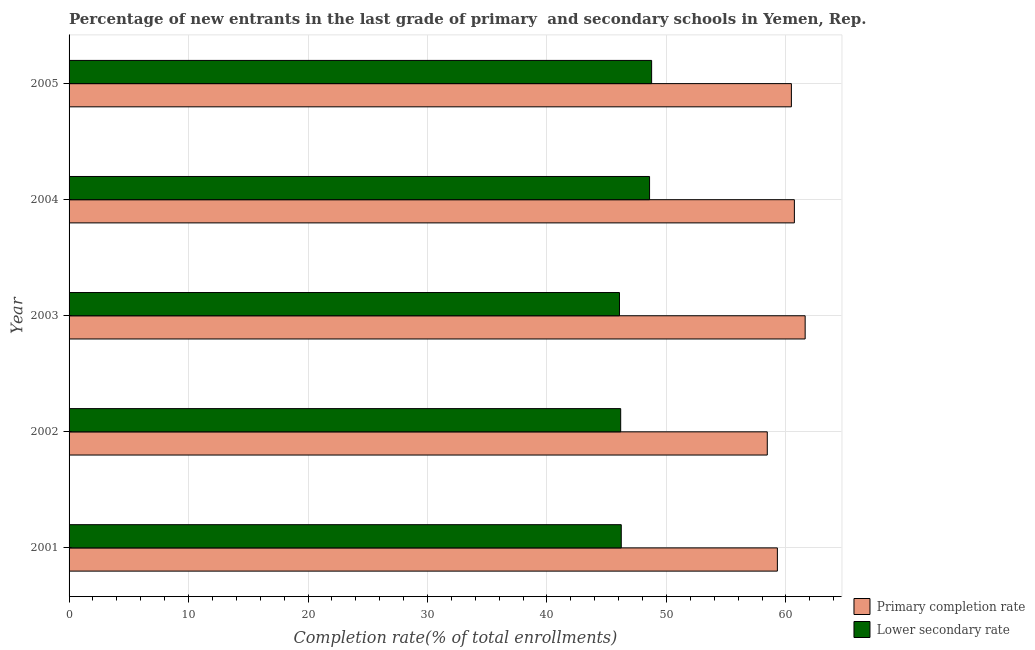How many different coloured bars are there?
Keep it short and to the point. 2. Are the number of bars on each tick of the Y-axis equal?
Make the answer very short. Yes. How many bars are there on the 4th tick from the top?
Give a very brief answer. 2. In how many cases, is the number of bars for a given year not equal to the number of legend labels?
Ensure brevity in your answer.  0. What is the completion rate in primary schools in 2003?
Provide a short and direct response. 61.61. Across all years, what is the maximum completion rate in secondary schools?
Offer a very short reply. 48.76. Across all years, what is the minimum completion rate in primary schools?
Provide a succinct answer. 58.44. What is the total completion rate in primary schools in the graph?
Your answer should be compact. 300.51. What is the difference between the completion rate in primary schools in 2001 and that in 2002?
Offer a terse response. 0.84. What is the difference between the completion rate in primary schools in 2002 and the completion rate in secondary schools in 2003?
Give a very brief answer. 12.37. What is the average completion rate in primary schools per year?
Your response must be concise. 60.1. In the year 2001, what is the difference between the completion rate in primary schools and completion rate in secondary schools?
Your response must be concise. 13.07. In how many years, is the completion rate in primary schools greater than 20 %?
Ensure brevity in your answer.  5. Is the difference between the completion rate in secondary schools in 2002 and 2005 greater than the difference between the completion rate in primary schools in 2002 and 2005?
Provide a succinct answer. No. What is the difference between the highest and the second highest completion rate in secondary schools?
Make the answer very short. 0.17. What is the difference between the highest and the lowest completion rate in secondary schools?
Give a very brief answer. 2.69. In how many years, is the completion rate in secondary schools greater than the average completion rate in secondary schools taken over all years?
Keep it short and to the point. 2. Is the sum of the completion rate in secondary schools in 2002 and 2005 greater than the maximum completion rate in primary schools across all years?
Your answer should be very brief. Yes. What does the 2nd bar from the top in 2002 represents?
Make the answer very short. Primary completion rate. What does the 1st bar from the bottom in 2004 represents?
Your response must be concise. Primary completion rate. Are all the bars in the graph horizontal?
Your response must be concise. Yes. Are the values on the major ticks of X-axis written in scientific E-notation?
Offer a terse response. No. Does the graph contain any zero values?
Your answer should be very brief. No. Does the graph contain grids?
Make the answer very short. Yes. What is the title of the graph?
Provide a short and direct response. Percentage of new entrants in the last grade of primary  and secondary schools in Yemen, Rep. What is the label or title of the X-axis?
Give a very brief answer. Completion rate(% of total enrollments). What is the label or title of the Y-axis?
Your answer should be compact. Year. What is the Completion rate(% of total enrollments) in Primary completion rate in 2001?
Give a very brief answer. 59.29. What is the Completion rate(% of total enrollments) of Lower secondary rate in 2001?
Offer a very short reply. 46.22. What is the Completion rate(% of total enrollments) in Primary completion rate in 2002?
Keep it short and to the point. 58.44. What is the Completion rate(% of total enrollments) in Lower secondary rate in 2002?
Provide a short and direct response. 46.17. What is the Completion rate(% of total enrollments) in Primary completion rate in 2003?
Give a very brief answer. 61.61. What is the Completion rate(% of total enrollments) of Lower secondary rate in 2003?
Keep it short and to the point. 46.07. What is the Completion rate(% of total enrollments) of Primary completion rate in 2004?
Offer a terse response. 60.71. What is the Completion rate(% of total enrollments) of Lower secondary rate in 2004?
Make the answer very short. 48.59. What is the Completion rate(% of total enrollments) of Primary completion rate in 2005?
Provide a succinct answer. 60.46. What is the Completion rate(% of total enrollments) of Lower secondary rate in 2005?
Offer a very short reply. 48.76. Across all years, what is the maximum Completion rate(% of total enrollments) of Primary completion rate?
Give a very brief answer. 61.61. Across all years, what is the maximum Completion rate(% of total enrollments) of Lower secondary rate?
Provide a short and direct response. 48.76. Across all years, what is the minimum Completion rate(% of total enrollments) of Primary completion rate?
Offer a terse response. 58.44. Across all years, what is the minimum Completion rate(% of total enrollments) of Lower secondary rate?
Your response must be concise. 46.07. What is the total Completion rate(% of total enrollments) in Primary completion rate in the graph?
Your response must be concise. 300.51. What is the total Completion rate(% of total enrollments) in Lower secondary rate in the graph?
Offer a terse response. 235.82. What is the difference between the Completion rate(% of total enrollments) in Primary completion rate in 2001 and that in 2002?
Give a very brief answer. 0.85. What is the difference between the Completion rate(% of total enrollments) of Lower secondary rate in 2001 and that in 2002?
Make the answer very short. 0.05. What is the difference between the Completion rate(% of total enrollments) in Primary completion rate in 2001 and that in 2003?
Provide a short and direct response. -2.33. What is the difference between the Completion rate(% of total enrollments) in Lower secondary rate in 2001 and that in 2003?
Your answer should be very brief. 0.15. What is the difference between the Completion rate(% of total enrollments) of Primary completion rate in 2001 and that in 2004?
Offer a terse response. -1.42. What is the difference between the Completion rate(% of total enrollments) in Lower secondary rate in 2001 and that in 2004?
Keep it short and to the point. -2.37. What is the difference between the Completion rate(% of total enrollments) in Primary completion rate in 2001 and that in 2005?
Your answer should be compact. -1.17. What is the difference between the Completion rate(% of total enrollments) of Lower secondary rate in 2001 and that in 2005?
Provide a succinct answer. -2.54. What is the difference between the Completion rate(% of total enrollments) in Primary completion rate in 2002 and that in 2003?
Your answer should be compact. -3.17. What is the difference between the Completion rate(% of total enrollments) in Lower secondary rate in 2002 and that in 2003?
Offer a terse response. 0.1. What is the difference between the Completion rate(% of total enrollments) of Primary completion rate in 2002 and that in 2004?
Ensure brevity in your answer.  -2.27. What is the difference between the Completion rate(% of total enrollments) of Lower secondary rate in 2002 and that in 2004?
Keep it short and to the point. -2.42. What is the difference between the Completion rate(% of total enrollments) in Primary completion rate in 2002 and that in 2005?
Your answer should be compact. -2.02. What is the difference between the Completion rate(% of total enrollments) of Lower secondary rate in 2002 and that in 2005?
Your answer should be compact. -2.59. What is the difference between the Completion rate(% of total enrollments) of Primary completion rate in 2003 and that in 2004?
Keep it short and to the point. 0.9. What is the difference between the Completion rate(% of total enrollments) of Lower secondary rate in 2003 and that in 2004?
Offer a very short reply. -2.52. What is the difference between the Completion rate(% of total enrollments) of Primary completion rate in 2003 and that in 2005?
Your answer should be very brief. 1.15. What is the difference between the Completion rate(% of total enrollments) in Lower secondary rate in 2003 and that in 2005?
Give a very brief answer. -2.69. What is the difference between the Completion rate(% of total enrollments) in Primary completion rate in 2004 and that in 2005?
Make the answer very short. 0.25. What is the difference between the Completion rate(% of total enrollments) in Lower secondary rate in 2004 and that in 2005?
Keep it short and to the point. -0.17. What is the difference between the Completion rate(% of total enrollments) of Primary completion rate in 2001 and the Completion rate(% of total enrollments) of Lower secondary rate in 2002?
Your answer should be very brief. 13.12. What is the difference between the Completion rate(% of total enrollments) in Primary completion rate in 2001 and the Completion rate(% of total enrollments) in Lower secondary rate in 2003?
Provide a succinct answer. 13.22. What is the difference between the Completion rate(% of total enrollments) of Primary completion rate in 2001 and the Completion rate(% of total enrollments) of Lower secondary rate in 2004?
Offer a very short reply. 10.7. What is the difference between the Completion rate(% of total enrollments) of Primary completion rate in 2001 and the Completion rate(% of total enrollments) of Lower secondary rate in 2005?
Offer a very short reply. 10.53. What is the difference between the Completion rate(% of total enrollments) in Primary completion rate in 2002 and the Completion rate(% of total enrollments) in Lower secondary rate in 2003?
Ensure brevity in your answer.  12.37. What is the difference between the Completion rate(% of total enrollments) of Primary completion rate in 2002 and the Completion rate(% of total enrollments) of Lower secondary rate in 2004?
Give a very brief answer. 9.85. What is the difference between the Completion rate(% of total enrollments) of Primary completion rate in 2002 and the Completion rate(% of total enrollments) of Lower secondary rate in 2005?
Provide a short and direct response. 9.68. What is the difference between the Completion rate(% of total enrollments) of Primary completion rate in 2003 and the Completion rate(% of total enrollments) of Lower secondary rate in 2004?
Your response must be concise. 13.02. What is the difference between the Completion rate(% of total enrollments) in Primary completion rate in 2003 and the Completion rate(% of total enrollments) in Lower secondary rate in 2005?
Keep it short and to the point. 12.85. What is the difference between the Completion rate(% of total enrollments) in Primary completion rate in 2004 and the Completion rate(% of total enrollments) in Lower secondary rate in 2005?
Provide a succinct answer. 11.95. What is the average Completion rate(% of total enrollments) in Primary completion rate per year?
Provide a short and direct response. 60.1. What is the average Completion rate(% of total enrollments) in Lower secondary rate per year?
Keep it short and to the point. 47.16. In the year 2001, what is the difference between the Completion rate(% of total enrollments) in Primary completion rate and Completion rate(% of total enrollments) in Lower secondary rate?
Offer a terse response. 13.07. In the year 2002, what is the difference between the Completion rate(% of total enrollments) in Primary completion rate and Completion rate(% of total enrollments) in Lower secondary rate?
Your response must be concise. 12.27. In the year 2003, what is the difference between the Completion rate(% of total enrollments) of Primary completion rate and Completion rate(% of total enrollments) of Lower secondary rate?
Provide a short and direct response. 15.54. In the year 2004, what is the difference between the Completion rate(% of total enrollments) in Primary completion rate and Completion rate(% of total enrollments) in Lower secondary rate?
Your response must be concise. 12.12. In the year 2005, what is the difference between the Completion rate(% of total enrollments) of Primary completion rate and Completion rate(% of total enrollments) of Lower secondary rate?
Offer a very short reply. 11.7. What is the ratio of the Completion rate(% of total enrollments) in Primary completion rate in 2001 to that in 2002?
Offer a terse response. 1.01. What is the ratio of the Completion rate(% of total enrollments) in Lower secondary rate in 2001 to that in 2002?
Your answer should be compact. 1. What is the ratio of the Completion rate(% of total enrollments) of Primary completion rate in 2001 to that in 2003?
Give a very brief answer. 0.96. What is the ratio of the Completion rate(% of total enrollments) in Primary completion rate in 2001 to that in 2004?
Provide a short and direct response. 0.98. What is the ratio of the Completion rate(% of total enrollments) in Lower secondary rate in 2001 to that in 2004?
Your answer should be very brief. 0.95. What is the ratio of the Completion rate(% of total enrollments) in Primary completion rate in 2001 to that in 2005?
Make the answer very short. 0.98. What is the ratio of the Completion rate(% of total enrollments) of Lower secondary rate in 2001 to that in 2005?
Make the answer very short. 0.95. What is the ratio of the Completion rate(% of total enrollments) of Primary completion rate in 2002 to that in 2003?
Your response must be concise. 0.95. What is the ratio of the Completion rate(% of total enrollments) of Lower secondary rate in 2002 to that in 2003?
Provide a short and direct response. 1. What is the ratio of the Completion rate(% of total enrollments) in Primary completion rate in 2002 to that in 2004?
Offer a very short reply. 0.96. What is the ratio of the Completion rate(% of total enrollments) of Lower secondary rate in 2002 to that in 2004?
Ensure brevity in your answer.  0.95. What is the ratio of the Completion rate(% of total enrollments) of Primary completion rate in 2002 to that in 2005?
Keep it short and to the point. 0.97. What is the ratio of the Completion rate(% of total enrollments) of Lower secondary rate in 2002 to that in 2005?
Provide a short and direct response. 0.95. What is the ratio of the Completion rate(% of total enrollments) of Primary completion rate in 2003 to that in 2004?
Keep it short and to the point. 1.01. What is the ratio of the Completion rate(% of total enrollments) in Lower secondary rate in 2003 to that in 2004?
Keep it short and to the point. 0.95. What is the ratio of the Completion rate(% of total enrollments) of Primary completion rate in 2003 to that in 2005?
Keep it short and to the point. 1.02. What is the ratio of the Completion rate(% of total enrollments) in Lower secondary rate in 2003 to that in 2005?
Your answer should be compact. 0.94. What is the difference between the highest and the second highest Completion rate(% of total enrollments) of Primary completion rate?
Your response must be concise. 0.9. What is the difference between the highest and the second highest Completion rate(% of total enrollments) in Lower secondary rate?
Provide a succinct answer. 0.17. What is the difference between the highest and the lowest Completion rate(% of total enrollments) in Primary completion rate?
Make the answer very short. 3.17. What is the difference between the highest and the lowest Completion rate(% of total enrollments) in Lower secondary rate?
Your answer should be compact. 2.69. 